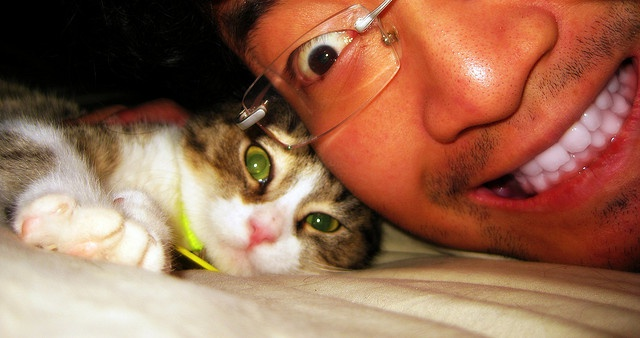Describe the objects in this image and their specific colors. I can see people in black, maroon, red, and brown tones, cat in black, ivory, tan, and olive tones, and bed in black, beige, and tan tones in this image. 